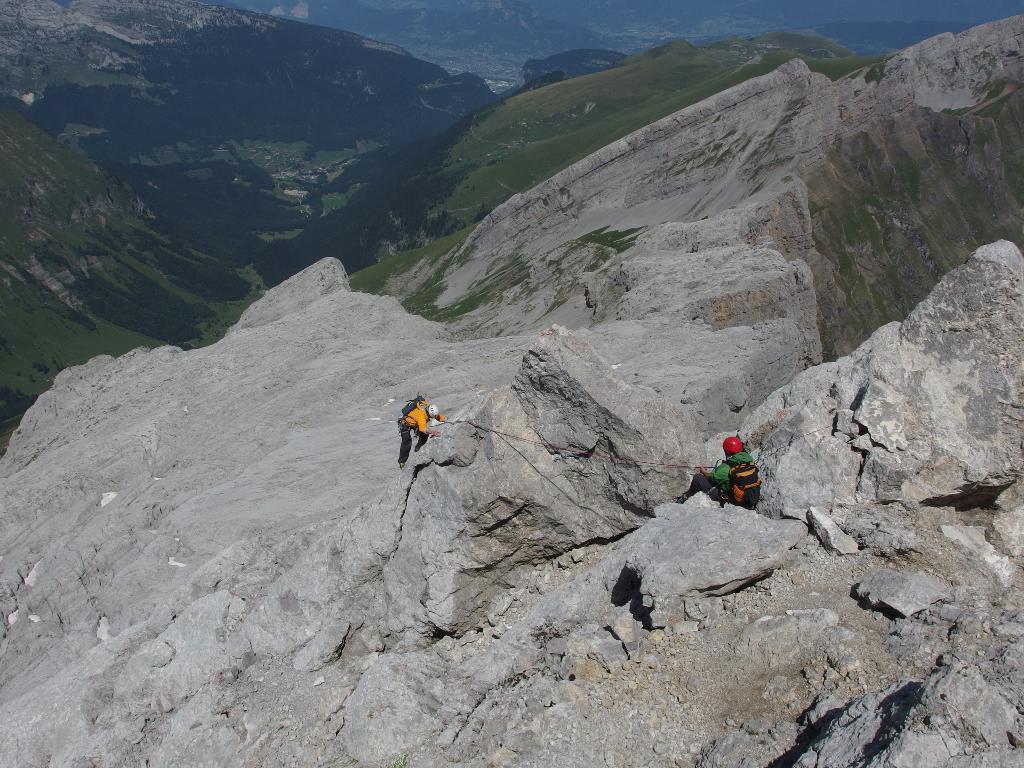Could you give a brief overview of what you see in this image? There are two people wore helmets and carrying bags. We can see hills, rope and grass. 